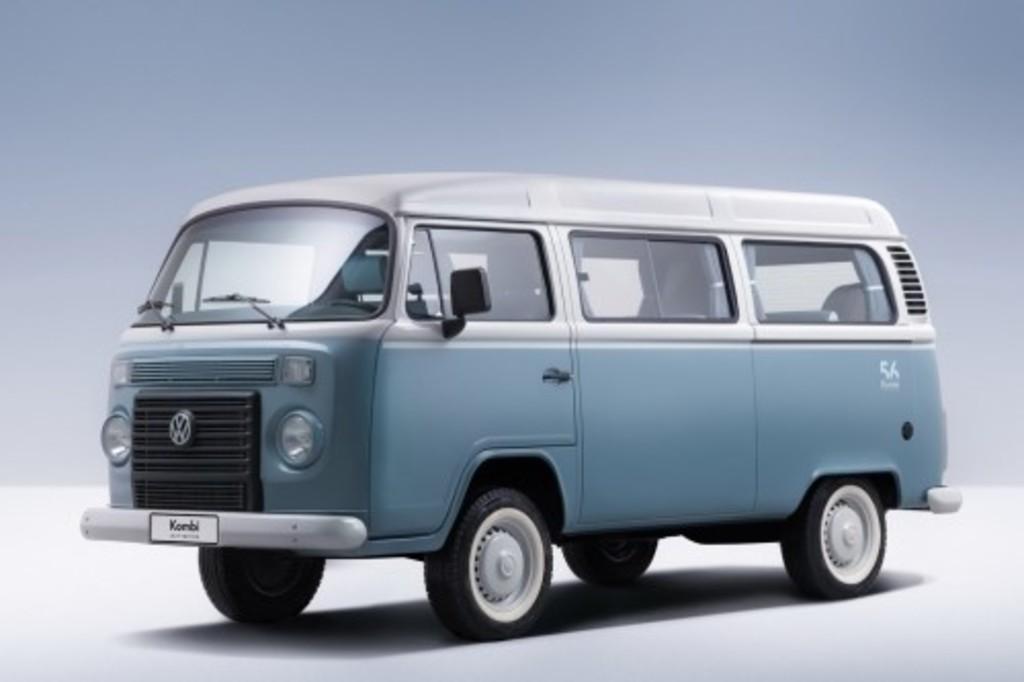Please provide a concise description of this image. In this picture we can see a vehicle and there is a white background. 